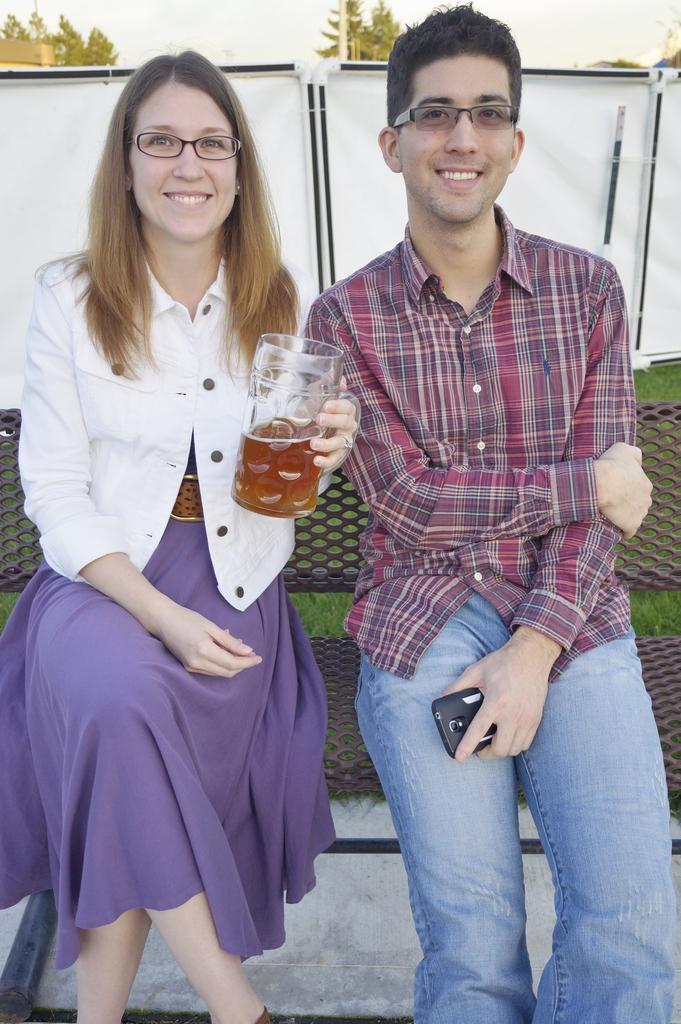Who are the people in the image? There is a woman and a man in the image. What are the woman and the man doing in the image? Both the woman and the man are sitting on a bench. What is the woman holding in the image? The woman is holding a mug. What is the man holding in the image? The man is holding a mobile. What type of kitty can be seen playing with the mug in the image? There is no kitty present in the image; the woman is holding a mug. 